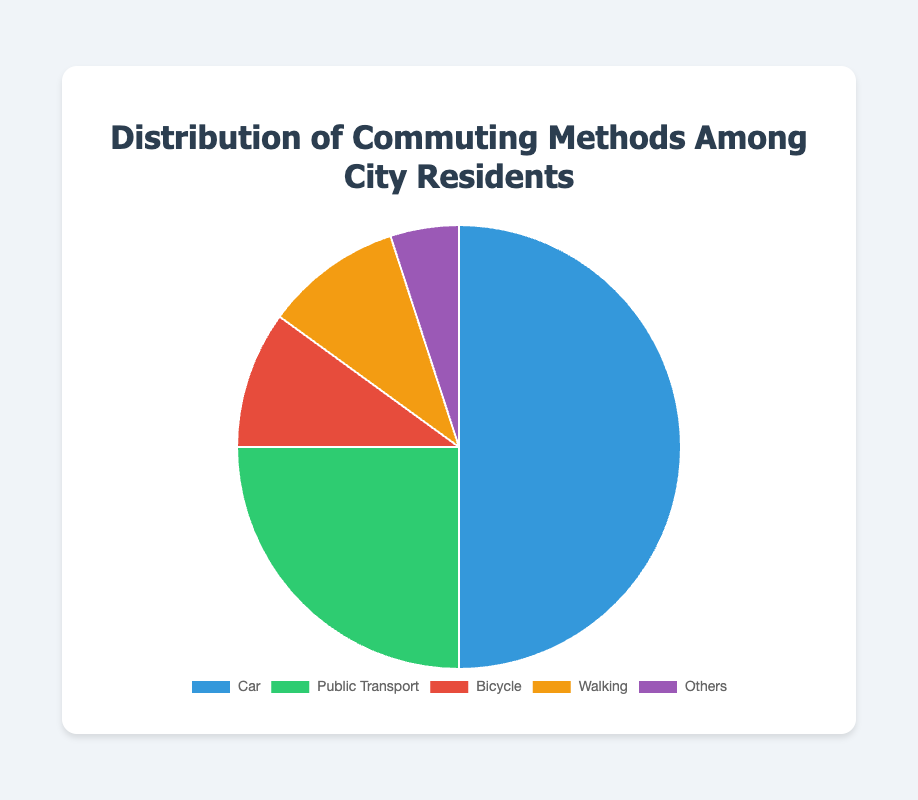Which commuting method has the highest percentage of use among city residents? By referring to the figure, the "Car" segment is the largest. Its stated percentage is 50%, which is higher than any other method.
Answer: Car Which commuting method has the smallest percentage? By analyzing the figure, the "Others" segment is the smallest with a percentage of 5%.
Answer: Others What is the combined percentage of residents who commute by bicycle and walking? To find the combined percentage, add the percentages for "Bicycle" (10%) and "Walking" (10%): 10% + 10% = 20%.
Answer: 20% Is the percentage of residents using public transport greater than those using bicycles and walking combined? We already calculated that the combined percentage for bicycles and walking is 20%. The percentage for public transport is 25%. Since 25% is greater than 20%, public transport is used more.
Answer: Yes How does the percentage of residents who commute by car compare to those who commute by public transport? The percentage of residents commuting by car is 50%, while the percentage for public transport is 25%. 50% is double 25%, so car use is twice as high.
Answer: Car use is twice as high What is the difference in percentage points between residents who commute by car and those who walk? The percentage of residents commuting by car is 50%, and for walking, it's 10%. The difference is 50% - 10% = 40%.
Answer: 40% Which commuting method has a segment colored in green? Referencing the visual attributes, "Public Transport" is associated with the color green.
Answer: Public Transport What percentage of residents use methods other than cars or public transport? Sum the percentages of methods other than car and public transport: "Bicycle" (10%) + "Walking" (10%) + "Others" (5%) = 25%.
Answer: 25% Which two commuting methods have equal percentages? Both "Bicycle" and "Walking" are labeled with 10%, so they are equal in percentage.
Answer: Bicycle and Walking What is the average percentage of the commuting methods? Sum the percentages of all commuting methods and divide by the number of methods: (50% + 25% + 10% + 10% + 5%) / 5 = 100% / 5 = 20%.
Answer: 20% 